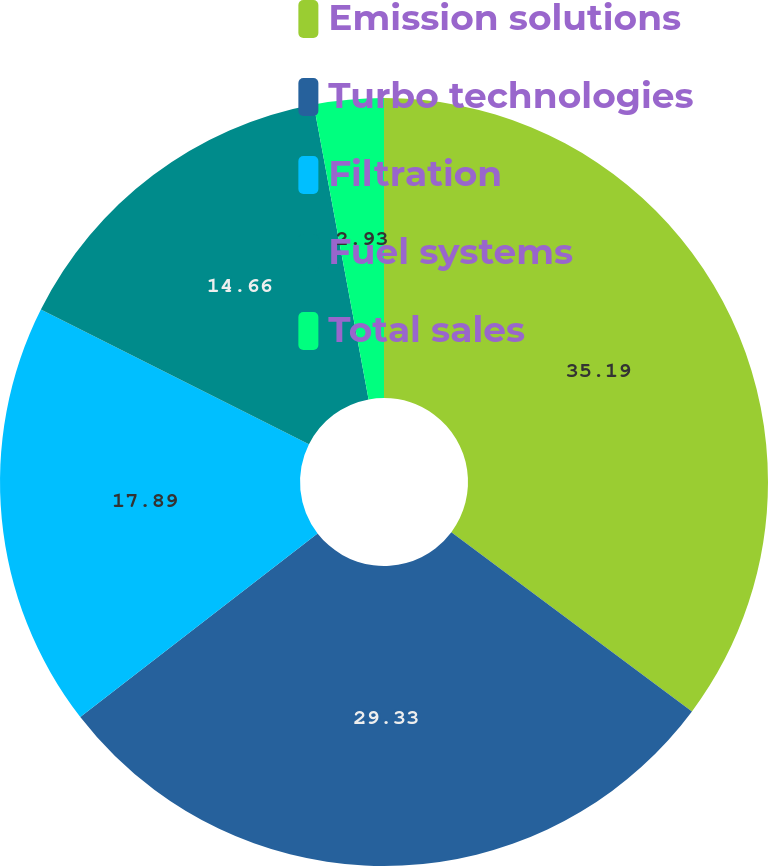Convert chart to OTSL. <chart><loc_0><loc_0><loc_500><loc_500><pie_chart><fcel>Emission solutions<fcel>Turbo technologies<fcel>Filtration<fcel>Fuel systems<fcel>Total sales<nl><fcel>35.19%<fcel>29.33%<fcel>17.89%<fcel>14.66%<fcel>2.93%<nl></chart> 